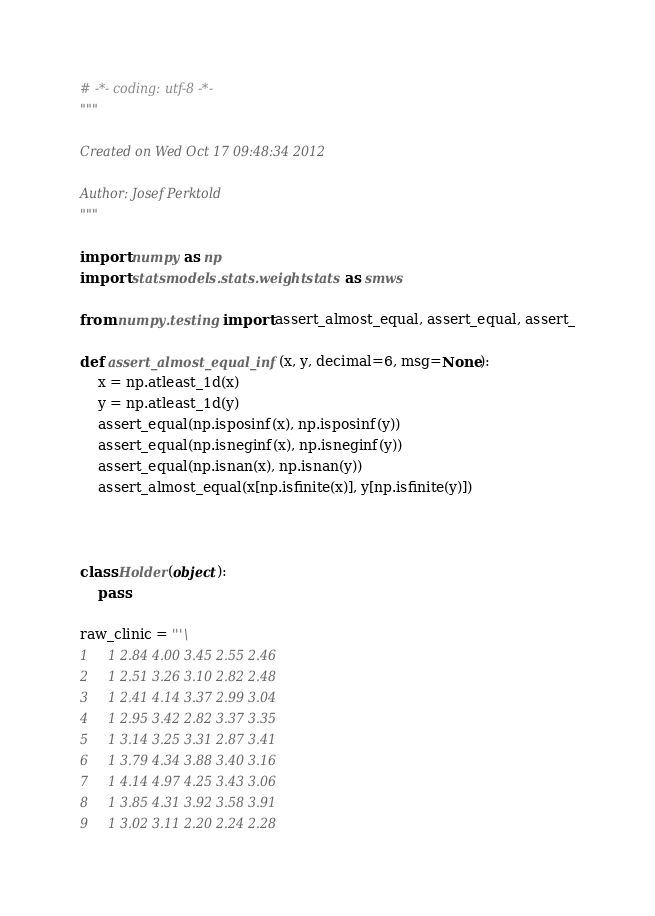<code> <loc_0><loc_0><loc_500><loc_500><_Python_># -*- coding: utf-8 -*-
"""

Created on Wed Oct 17 09:48:34 2012

Author: Josef Perktold
"""

import numpy as np
import statsmodels.stats.weightstats as smws

from numpy.testing import assert_almost_equal, assert_equal, assert_

def assert_almost_equal_inf(x, y, decimal=6, msg=None):
    x = np.atleast_1d(x)
    y = np.atleast_1d(y)
    assert_equal(np.isposinf(x), np.isposinf(y))
    assert_equal(np.isneginf(x), np.isneginf(y))
    assert_equal(np.isnan(x), np.isnan(y))
    assert_almost_equal(x[np.isfinite(x)], y[np.isfinite(y)])



class Holder(object):
    pass

raw_clinic = '''\
1     1 2.84 4.00 3.45 2.55 2.46
2     1 2.51 3.26 3.10 2.82 2.48
3     1 2.41 4.14 3.37 2.99 3.04
4     1 2.95 3.42 2.82 3.37 3.35
5     1 3.14 3.25 3.31 2.87 3.41
6     1 3.79 4.34 3.88 3.40 3.16
7     1 4.14 4.97 4.25 3.43 3.06
8     1 3.85 4.31 3.92 3.58 3.91
9     1 3.02 3.11 2.20 2.24 2.28</code> 